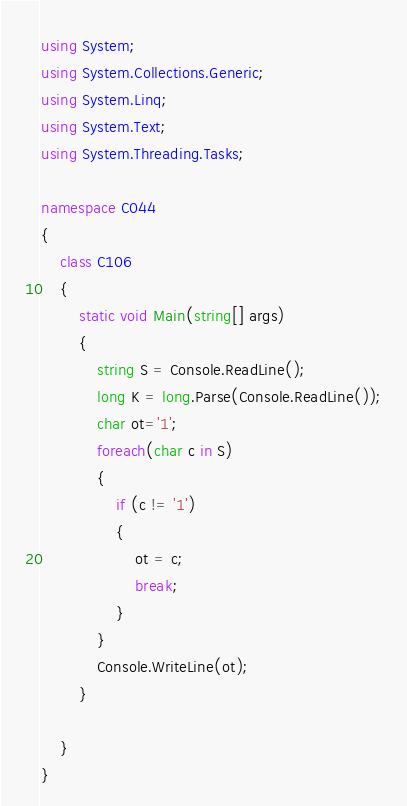<code> <loc_0><loc_0><loc_500><loc_500><_C#_>using System;
using System.Collections.Generic;
using System.Linq;
using System.Text;
using System.Threading.Tasks;

namespace C044
{
    class C106
    {
        static void Main(string[] args)
        {
            string S = Console.ReadLine();
            long K = long.Parse(Console.ReadLine());
            char ot='1';
            foreach(char c in S)
            {
                if (c != '1')
                {
                    ot = c;
                    break;
                }
            }
            Console.WriteLine(ot);
        }

    }
}
</code> 